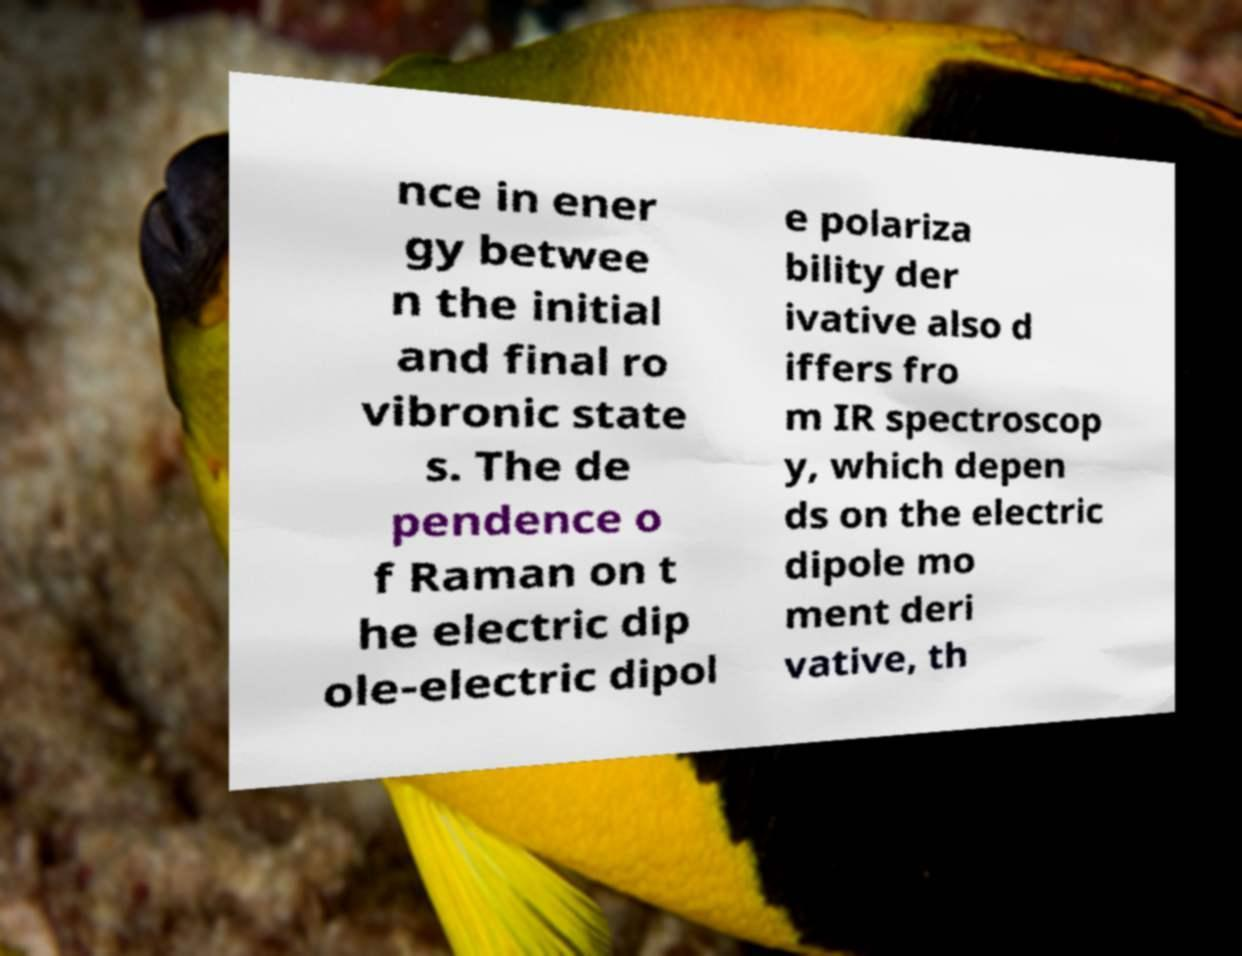Could you extract and type out the text from this image? nce in ener gy betwee n the initial and final ro vibronic state s. The de pendence o f Raman on t he electric dip ole-electric dipol e polariza bility der ivative also d iffers fro m IR spectroscop y, which depen ds on the electric dipole mo ment deri vative, th 